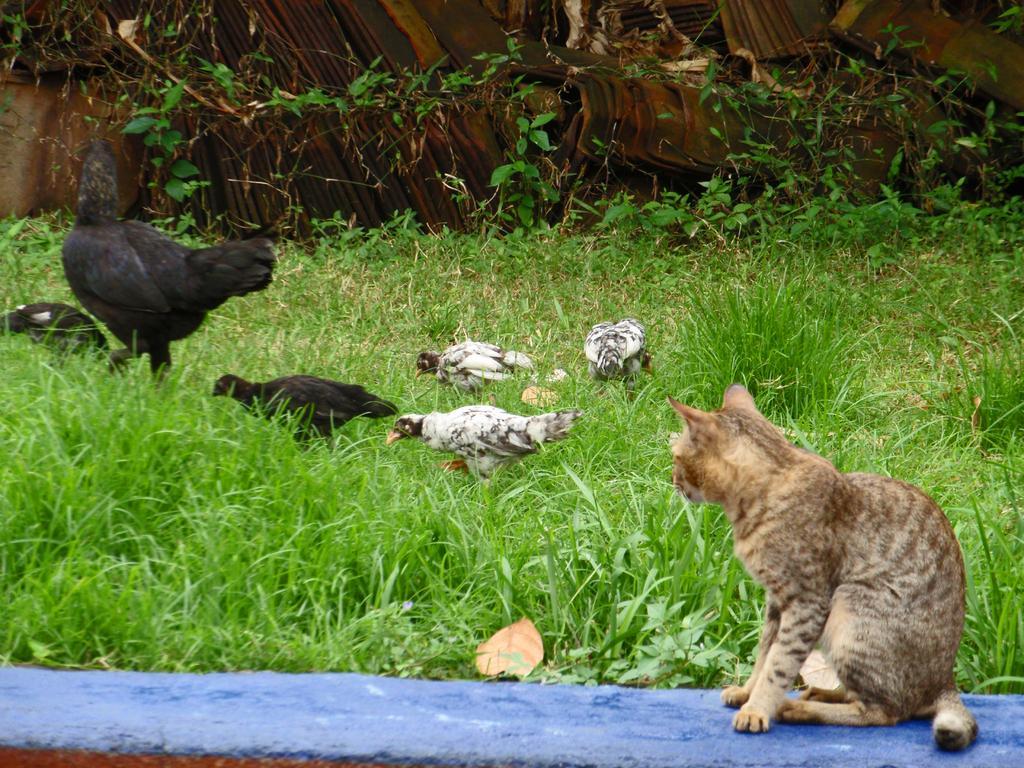Please provide a concise description of this image. In this image, I can see a cat sitting on the wall. This is the grass. I can see a flock of hens. I think these are the plants. 